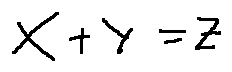Convert formula to latex. <formula><loc_0><loc_0><loc_500><loc_500>x + y = z</formula> 